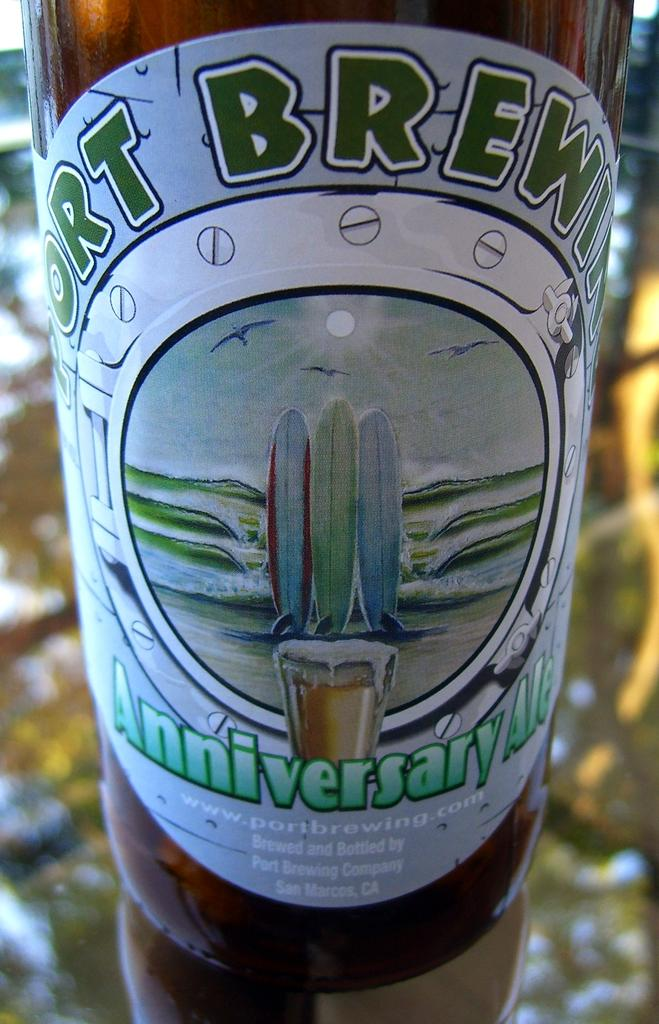What object is present on the table in the image? There is a bottle on the table in the image. What brand is the bottle in the image? The bottle in the image is of the brand Port Brewing. Is there a chair visible in the image? There is no mention of a chair in the provided facts, so we cannot determine if one is present in the image. 